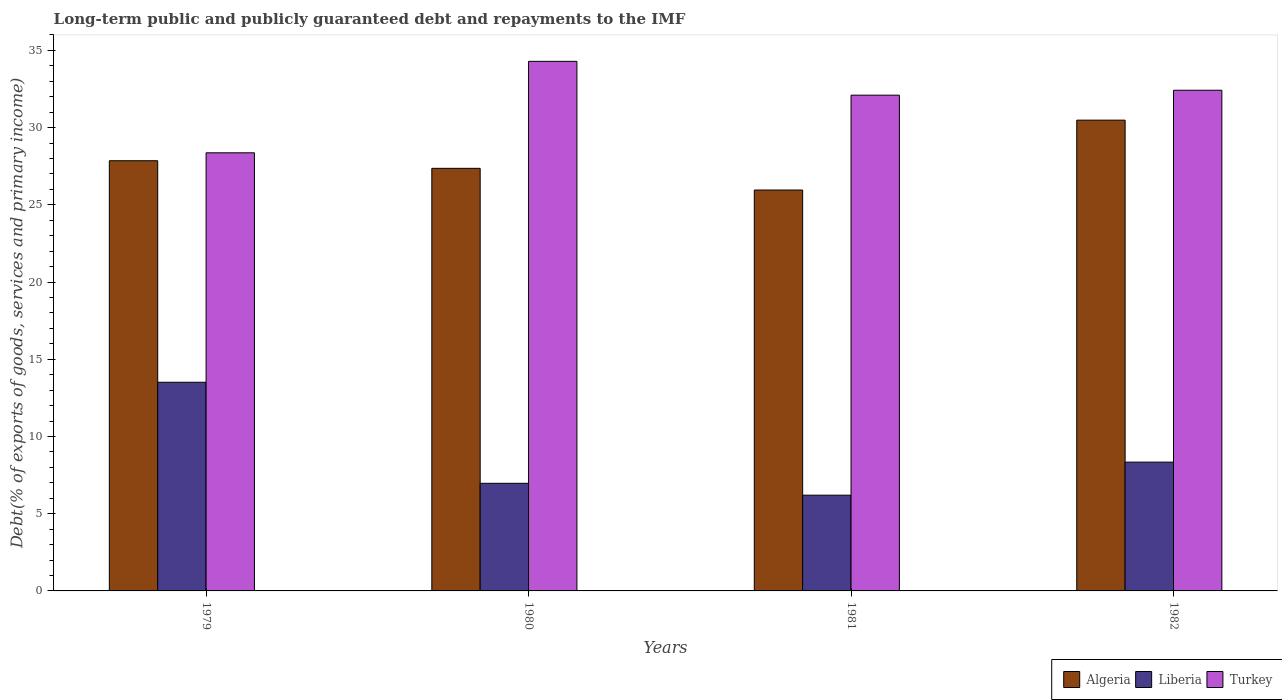Are the number of bars on each tick of the X-axis equal?
Provide a succinct answer. Yes. How many bars are there on the 4th tick from the right?
Your response must be concise. 3. What is the debt and repayments in Turkey in 1979?
Ensure brevity in your answer.  28.37. Across all years, what is the maximum debt and repayments in Liberia?
Provide a succinct answer. 13.51. Across all years, what is the minimum debt and repayments in Liberia?
Provide a short and direct response. 6.2. In which year was the debt and repayments in Turkey maximum?
Provide a succinct answer. 1980. What is the total debt and repayments in Liberia in the graph?
Provide a succinct answer. 35.02. What is the difference between the debt and repayments in Algeria in 1979 and that in 1981?
Offer a very short reply. 1.9. What is the difference between the debt and repayments in Liberia in 1981 and the debt and repayments in Algeria in 1980?
Offer a very short reply. -21.17. What is the average debt and repayments in Algeria per year?
Provide a short and direct response. 27.92. In the year 1981, what is the difference between the debt and repayments in Algeria and debt and repayments in Liberia?
Give a very brief answer. 19.76. What is the ratio of the debt and repayments in Liberia in 1979 to that in 1982?
Your answer should be compact. 1.62. Is the difference between the debt and repayments in Algeria in 1979 and 1982 greater than the difference between the debt and repayments in Liberia in 1979 and 1982?
Give a very brief answer. No. What is the difference between the highest and the second highest debt and repayments in Turkey?
Your response must be concise. 1.87. What is the difference between the highest and the lowest debt and repayments in Turkey?
Provide a short and direct response. 5.92. What does the 1st bar from the left in 1982 represents?
Offer a very short reply. Algeria. What does the 3rd bar from the right in 1979 represents?
Your response must be concise. Algeria. How many bars are there?
Give a very brief answer. 12. Are all the bars in the graph horizontal?
Offer a very short reply. No. Are the values on the major ticks of Y-axis written in scientific E-notation?
Provide a succinct answer. No. Does the graph contain any zero values?
Keep it short and to the point. No. Where does the legend appear in the graph?
Make the answer very short. Bottom right. How many legend labels are there?
Offer a very short reply. 3. How are the legend labels stacked?
Make the answer very short. Horizontal. What is the title of the graph?
Offer a very short reply. Long-term public and publicly guaranteed debt and repayments to the IMF. What is the label or title of the Y-axis?
Give a very brief answer. Debt(% of exports of goods, services and primary income). What is the Debt(% of exports of goods, services and primary income) in Algeria in 1979?
Your response must be concise. 27.86. What is the Debt(% of exports of goods, services and primary income) of Liberia in 1979?
Keep it short and to the point. 13.51. What is the Debt(% of exports of goods, services and primary income) of Turkey in 1979?
Keep it short and to the point. 28.37. What is the Debt(% of exports of goods, services and primary income) of Algeria in 1980?
Your response must be concise. 27.37. What is the Debt(% of exports of goods, services and primary income) of Liberia in 1980?
Make the answer very short. 6.97. What is the Debt(% of exports of goods, services and primary income) of Turkey in 1980?
Your answer should be compact. 34.29. What is the Debt(% of exports of goods, services and primary income) in Algeria in 1981?
Your answer should be compact. 25.96. What is the Debt(% of exports of goods, services and primary income) in Liberia in 1981?
Your response must be concise. 6.2. What is the Debt(% of exports of goods, services and primary income) of Turkey in 1981?
Keep it short and to the point. 32.1. What is the Debt(% of exports of goods, services and primary income) in Algeria in 1982?
Ensure brevity in your answer.  30.49. What is the Debt(% of exports of goods, services and primary income) in Liberia in 1982?
Give a very brief answer. 8.34. What is the Debt(% of exports of goods, services and primary income) in Turkey in 1982?
Offer a very short reply. 32.42. Across all years, what is the maximum Debt(% of exports of goods, services and primary income) in Algeria?
Keep it short and to the point. 30.49. Across all years, what is the maximum Debt(% of exports of goods, services and primary income) of Liberia?
Your answer should be compact. 13.51. Across all years, what is the maximum Debt(% of exports of goods, services and primary income) of Turkey?
Your response must be concise. 34.29. Across all years, what is the minimum Debt(% of exports of goods, services and primary income) in Algeria?
Give a very brief answer. 25.96. Across all years, what is the minimum Debt(% of exports of goods, services and primary income) in Liberia?
Your response must be concise. 6.2. Across all years, what is the minimum Debt(% of exports of goods, services and primary income) of Turkey?
Make the answer very short. 28.37. What is the total Debt(% of exports of goods, services and primary income) of Algeria in the graph?
Offer a very short reply. 111.67. What is the total Debt(% of exports of goods, services and primary income) of Liberia in the graph?
Make the answer very short. 35.02. What is the total Debt(% of exports of goods, services and primary income) of Turkey in the graph?
Make the answer very short. 127.19. What is the difference between the Debt(% of exports of goods, services and primary income) of Algeria in 1979 and that in 1980?
Keep it short and to the point. 0.49. What is the difference between the Debt(% of exports of goods, services and primary income) of Liberia in 1979 and that in 1980?
Offer a very short reply. 6.54. What is the difference between the Debt(% of exports of goods, services and primary income) of Turkey in 1979 and that in 1980?
Offer a terse response. -5.92. What is the difference between the Debt(% of exports of goods, services and primary income) in Algeria in 1979 and that in 1981?
Your response must be concise. 1.9. What is the difference between the Debt(% of exports of goods, services and primary income) in Liberia in 1979 and that in 1981?
Ensure brevity in your answer.  7.31. What is the difference between the Debt(% of exports of goods, services and primary income) of Turkey in 1979 and that in 1981?
Ensure brevity in your answer.  -3.73. What is the difference between the Debt(% of exports of goods, services and primary income) in Algeria in 1979 and that in 1982?
Provide a succinct answer. -2.63. What is the difference between the Debt(% of exports of goods, services and primary income) in Liberia in 1979 and that in 1982?
Provide a short and direct response. 5.17. What is the difference between the Debt(% of exports of goods, services and primary income) in Turkey in 1979 and that in 1982?
Offer a terse response. -4.05. What is the difference between the Debt(% of exports of goods, services and primary income) of Algeria in 1980 and that in 1981?
Your answer should be very brief. 1.4. What is the difference between the Debt(% of exports of goods, services and primary income) in Liberia in 1980 and that in 1981?
Provide a succinct answer. 0.77. What is the difference between the Debt(% of exports of goods, services and primary income) in Turkey in 1980 and that in 1981?
Provide a short and direct response. 2.19. What is the difference between the Debt(% of exports of goods, services and primary income) in Algeria in 1980 and that in 1982?
Your answer should be very brief. -3.12. What is the difference between the Debt(% of exports of goods, services and primary income) of Liberia in 1980 and that in 1982?
Offer a very short reply. -1.37. What is the difference between the Debt(% of exports of goods, services and primary income) in Turkey in 1980 and that in 1982?
Provide a succinct answer. 1.87. What is the difference between the Debt(% of exports of goods, services and primary income) of Algeria in 1981 and that in 1982?
Ensure brevity in your answer.  -4.52. What is the difference between the Debt(% of exports of goods, services and primary income) of Liberia in 1981 and that in 1982?
Offer a terse response. -2.14. What is the difference between the Debt(% of exports of goods, services and primary income) in Turkey in 1981 and that in 1982?
Your answer should be compact. -0.32. What is the difference between the Debt(% of exports of goods, services and primary income) in Algeria in 1979 and the Debt(% of exports of goods, services and primary income) in Liberia in 1980?
Give a very brief answer. 20.89. What is the difference between the Debt(% of exports of goods, services and primary income) in Algeria in 1979 and the Debt(% of exports of goods, services and primary income) in Turkey in 1980?
Your answer should be very brief. -6.44. What is the difference between the Debt(% of exports of goods, services and primary income) in Liberia in 1979 and the Debt(% of exports of goods, services and primary income) in Turkey in 1980?
Offer a terse response. -20.78. What is the difference between the Debt(% of exports of goods, services and primary income) of Algeria in 1979 and the Debt(% of exports of goods, services and primary income) of Liberia in 1981?
Provide a short and direct response. 21.66. What is the difference between the Debt(% of exports of goods, services and primary income) in Algeria in 1979 and the Debt(% of exports of goods, services and primary income) in Turkey in 1981?
Your response must be concise. -4.25. What is the difference between the Debt(% of exports of goods, services and primary income) of Liberia in 1979 and the Debt(% of exports of goods, services and primary income) of Turkey in 1981?
Keep it short and to the point. -18.59. What is the difference between the Debt(% of exports of goods, services and primary income) in Algeria in 1979 and the Debt(% of exports of goods, services and primary income) in Liberia in 1982?
Provide a succinct answer. 19.52. What is the difference between the Debt(% of exports of goods, services and primary income) of Algeria in 1979 and the Debt(% of exports of goods, services and primary income) of Turkey in 1982?
Provide a succinct answer. -4.56. What is the difference between the Debt(% of exports of goods, services and primary income) in Liberia in 1979 and the Debt(% of exports of goods, services and primary income) in Turkey in 1982?
Your answer should be very brief. -18.91. What is the difference between the Debt(% of exports of goods, services and primary income) in Algeria in 1980 and the Debt(% of exports of goods, services and primary income) in Liberia in 1981?
Your response must be concise. 21.17. What is the difference between the Debt(% of exports of goods, services and primary income) in Algeria in 1980 and the Debt(% of exports of goods, services and primary income) in Turkey in 1981?
Keep it short and to the point. -4.74. What is the difference between the Debt(% of exports of goods, services and primary income) of Liberia in 1980 and the Debt(% of exports of goods, services and primary income) of Turkey in 1981?
Your answer should be very brief. -25.14. What is the difference between the Debt(% of exports of goods, services and primary income) of Algeria in 1980 and the Debt(% of exports of goods, services and primary income) of Liberia in 1982?
Give a very brief answer. 19.03. What is the difference between the Debt(% of exports of goods, services and primary income) in Algeria in 1980 and the Debt(% of exports of goods, services and primary income) in Turkey in 1982?
Your response must be concise. -5.06. What is the difference between the Debt(% of exports of goods, services and primary income) of Liberia in 1980 and the Debt(% of exports of goods, services and primary income) of Turkey in 1982?
Offer a terse response. -25.45. What is the difference between the Debt(% of exports of goods, services and primary income) of Algeria in 1981 and the Debt(% of exports of goods, services and primary income) of Liberia in 1982?
Offer a very short reply. 17.62. What is the difference between the Debt(% of exports of goods, services and primary income) in Algeria in 1981 and the Debt(% of exports of goods, services and primary income) in Turkey in 1982?
Give a very brief answer. -6.46. What is the difference between the Debt(% of exports of goods, services and primary income) of Liberia in 1981 and the Debt(% of exports of goods, services and primary income) of Turkey in 1982?
Keep it short and to the point. -26.22. What is the average Debt(% of exports of goods, services and primary income) of Algeria per year?
Give a very brief answer. 27.92. What is the average Debt(% of exports of goods, services and primary income) of Liberia per year?
Your answer should be compact. 8.75. What is the average Debt(% of exports of goods, services and primary income) in Turkey per year?
Give a very brief answer. 31.8. In the year 1979, what is the difference between the Debt(% of exports of goods, services and primary income) in Algeria and Debt(% of exports of goods, services and primary income) in Liberia?
Your response must be concise. 14.35. In the year 1979, what is the difference between the Debt(% of exports of goods, services and primary income) in Algeria and Debt(% of exports of goods, services and primary income) in Turkey?
Your answer should be compact. -0.51. In the year 1979, what is the difference between the Debt(% of exports of goods, services and primary income) in Liberia and Debt(% of exports of goods, services and primary income) in Turkey?
Keep it short and to the point. -14.86. In the year 1980, what is the difference between the Debt(% of exports of goods, services and primary income) of Algeria and Debt(% of exports of goods, services and primary income) of Liberia?
Make the answer very short. 20.4. In the year 1980, what is the difference between the Debt(% of exports of goods, services and primary income) in Algeria and Debt(% of exports of goods, services and primary income) in Turkey?
Offer a very short reply. -6.93. In the year 1980, what is the difference between the Debt(% of exports of goods, services and primary income) of Liberia and Debt(% of exports of goods, services and primary income) of Turkey?
Offer a terse response. -27.32. In the year 1981, what is the difference between the Debt(% of exports of goods, services and primary income) in Algeria and Debt(% of exports of goods, services and primary income) in Liberia?
Ensure brevity in your answer.  19.76. In the year 1981, what is the difference between the Debt(% of exports of goods, services and primary income) in Algeria and Debt(% of exports of goods, services and primary income) in Turkey?
Your response must be concise. -6.14. In the year 1981, what is the difference between the Debt(% of exports of goods, services and primary income) of Liberia and Debt(% of exports of goods, services and primary income) of Turkey?
Your answer should be very brief. -25.9. In the year 1982, what is the difference between the Debt(% of exports of goods, services and primary income) in Algeria and Debt(% of exports of goods, services and primary income) in Liberia?
Your answer should be compact. 22.15. In the year 1982, what is the difference between the Debt(% of exports of goods, services and primary income) in Algeria and Debt(% of exports of goods, services and primary income) in Turkey?
Offer a terse response. -1.94. In the year 1982, what is the difference between the Debt(% of exports of goods, services and primary income) in Liberia and Debt(% of exports of goods, services and primary income) in Turkey?
Ensure brevity in your answer.  -24.08. What is the ratio of the Debt(% of exports of goods, services and primary income) in Liberia in 1979 to that in 1980?
Your answer should be compact. 1.94. What is the ratio of the Debt(% of exports of goods, services and primary income) in Turkey in 1979 to that in 1980?
Offer a very short reply. 0.83. What is the ratio of the Debt(% of exports of goods, services and primary income) in Algeria in 1979 to that in 1981?
Give a very brief answer. 1.07. What is the ratio of the Debt(% of exports of goods, services and primary income) in Liberia in 1979 to that in 1981?
Your answer should be compact. 2.18. What is the ratio of the Debt(% of exports of goods, services and primary income) of Turkey in 1979 to that in 1981?
Provide a short and direct response. 0.88. What is the ratio of the Debt(% of exports of goods, services and primary income) in Algeria in 1979 to that in 1982?
Your answer should be very brief. 0.91. What is the ratio of the Debt(% of exports of goods, services and primary income) of Liberia in 1979 to that in 1982?
Offer a terse response. 1.62. What is the ratio of the Debt(% of exports of goods, services and primary income) of Turkey in 1979 to that in 1982?
Give a very brief answer. 0.88. What is the ratio of the Debt(% of exports of goods, services and primary income) in Algeria in 1980 to that in 1981?
Provide a short and direct response. 1.05. What is the ratio of the Debt(% of exports of goods, services and primary income) in Liberia in 1980 to that in 1981?
Provide a short and direct response. 1.12. What is the ratio of the Debt(% of exports of goods, services and primary income) in Turkey in 1980 to that in 1981?
Your answer should be compact. 1.07. What is the ratio of the Debt(% of exports of goods, services and primary income) of Algeria in 1980 to that in 1982?
Your answer should be very brief. 0.9. What is the ratio of the Debt(% of exports of goods, services and primary income) of Liberia in 1980 to that in 1982?
Your response must be concise. 0.84. What is the ratio of the Debt(% of exports of goods, services and primary income) in Turkey in 1980 to that in 1982?
Your response must be concise. 1.06. What is the ratio of the Debt(% of exports of goods, services and primary income) in Algeria in 1981 to that in 1982?
Your response must be concise. 0.85. What is the ratio of the Debt(% of exports of goods, services and primary income) in Liberia in 1981 to that in 1982?
Make the answer very short. 0.74. What is the ratio of the Debt(% of exports of goods, services and primary income) of Turkey in 1981 to that in 1982?
Your response must be concise. 0.99. What is the difference between the highest and the second highest Debt(% of exports of goods, services and primary income) of Algeria?
Offer a terse response. 2.63. What is the difference between the highest and the second highest Debt(% of exports of goods, services and primary income) of Liberia?
Make the answer very short. 5.17. What is the difference between the highest and the second highest Debt(% of exports of goods, services and primary income) of Turkey?
Offer a terse response. 1.87. What is the difference between the highest and the lowest Debt(% of exports of goods, services and primary income) in Algeria?
Offer a very short reply. 4.52. What is the difference between the highest and the lowest Debt(% of exports of goods, services and primary income) in Liberia?
Provide a short and direct response. 7.31. What is the difference between the highest and the lowest Debt(% of exports of goods, services and primary income) of Turkey?
Provide a short and direct response. 5.92. 